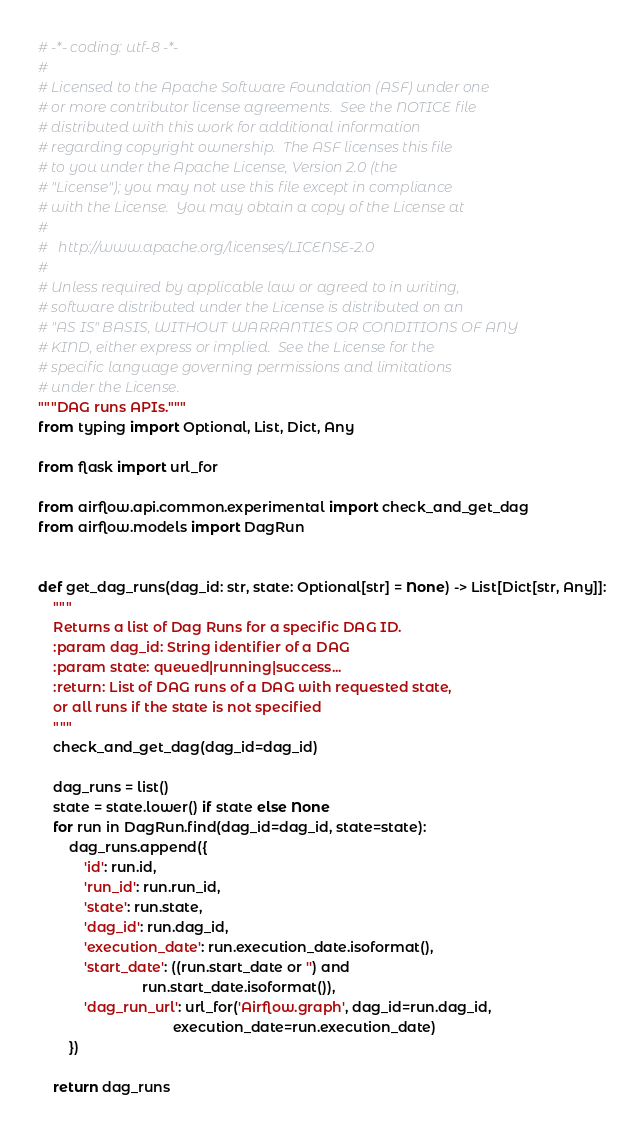<code> <loc_0><loc_0><loc_500><loc_500><_Python_># -*- coding: utf-8 -*-
#
# Licensed to the Apache Software Foundation (ASF) under one
# or more contributor license agreements.  See the NOTICE file
# distributed with this work for additional information
# regarding copyright ownership.  The ASF licenses this file
# to you under the Apache License, Version 2.0 (the
# "License"); you may not use this file except in compliance
# with the License.  You may obtain a copy of the License at
#
#   http://www.apache.org/licenses/LICENSE-2.0
#
# Unless required by applicable law or agreed to in writing,
# software distributed under the License is distributed on an
# "AS IS" BASIS, WITHOUT WARRANTIES OR CONDITIONS OF ANY
# KIND, either express or implied.  See the License for the
# specific language governing permissions and limitations
# under the License.
"""DAG runs APIs."""
from typing import Optional, List, Dict, Any

from flask import url_for

from airflow.api.common.experimental import check_and_get_dag
from airflow.models import DagRun


def get_dag_runs(dag_id: str, state: Optional[str] = None) -> List[Dict[str, Any]]:
    """
    Returns a list of Dag Runs for a specific DAG ID.
    :param dag_id: String identifier of a DAG
    :param state: queued|running|success...
    :return: List of DAG runs of a DAG with requested state,
    or all runs if the state is not specified
    """
    check_and_get_dag(dag_id=dag_id)

    dag_runs = list()
    state = state.lower() if state else None
    for run in DagRun.find(dag_id=dag_id, state=state):
        dag_runs.append({
            'id': run.id,
            'run_id': run.run_id,
            'state': run.state,
            'dag_id': run.dag_id,
            'execution_date': run.execution_date.isoformat(),
            'start_date': ((run.start_date or '') and
                           run.start_date.isoformat()),
            'dag_run_url': url_for('Airflow.graph', dag_id=run.dag_id,
                                   execution_date=run.execution_date)
        })

    return dag_runs
</code> 